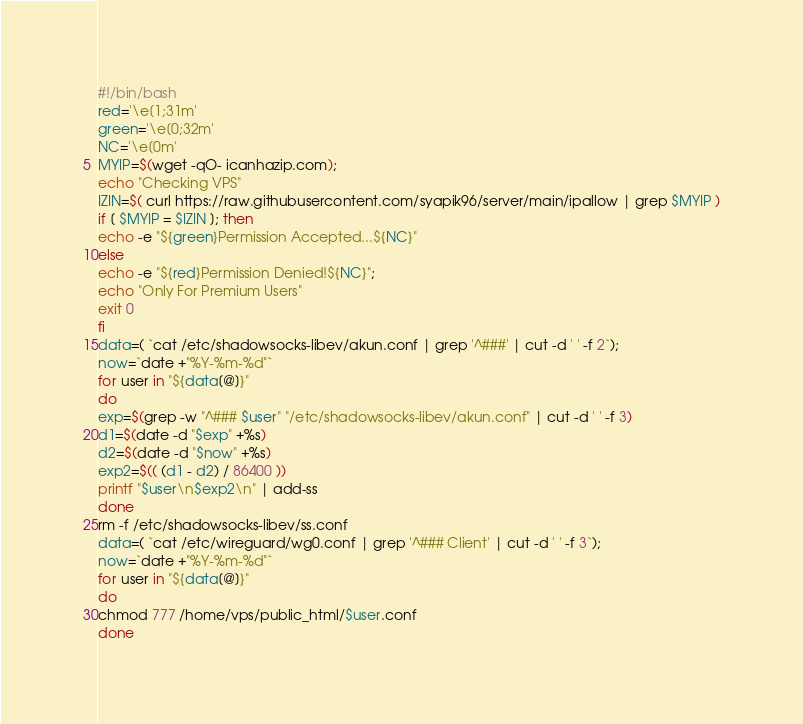Convert code to text. <code><loc_0><loc_0><loc_500><loc_500><_Bash_>#!/bin/bash
red='\e[1;31m'
green='\e[0;32m'
NC='\e[0m'
MYIP=$(wget -qO- icanhazip.com);
echo "Checking VPS"
IZIN=$( curl https://raw.githubusercontent.com/syapik96/server/main/ipallow | grep $MYIP )
if [ $MYIP = $IZIN ]; then
echo -e "${green}Permission Accepted...${NC}"
else
echo -e "${red}Permission Denied!${NC}";
echo "Only For Premium Users"
exit 0
fi
data=( `cat /etc/shadowsocks-libev/akun.conf | grep '^###' | cut -d ' ' -f 2`);
now=`date +"%Y-%m-%d"`
for user in "${data[@]}"
do
exp=$(grep -w "^### $user" "/etc/shadowsocks-libev/akun.conf" | cut -d ' ' -f 3)
d1=$(date -d "$exp" +%s)
d2=$(date -d "$now" +%s)
exp2=$(( (d1 - d2) / 86400 ))
printf "$user\n$exp2\n" | add-ss
done
rm -f /etc/shadowsocks-libev/ss.conf
data=( `cat /etc/wireguard/wg0.conf | grep '^### Client' | cut -d ' ' -f 3`);
now=`date +"%Y-%m-%d"`
for user in "${data[@]}"
do
chmod 777 /home/vps/public_html/$user.conf
done
</code> 